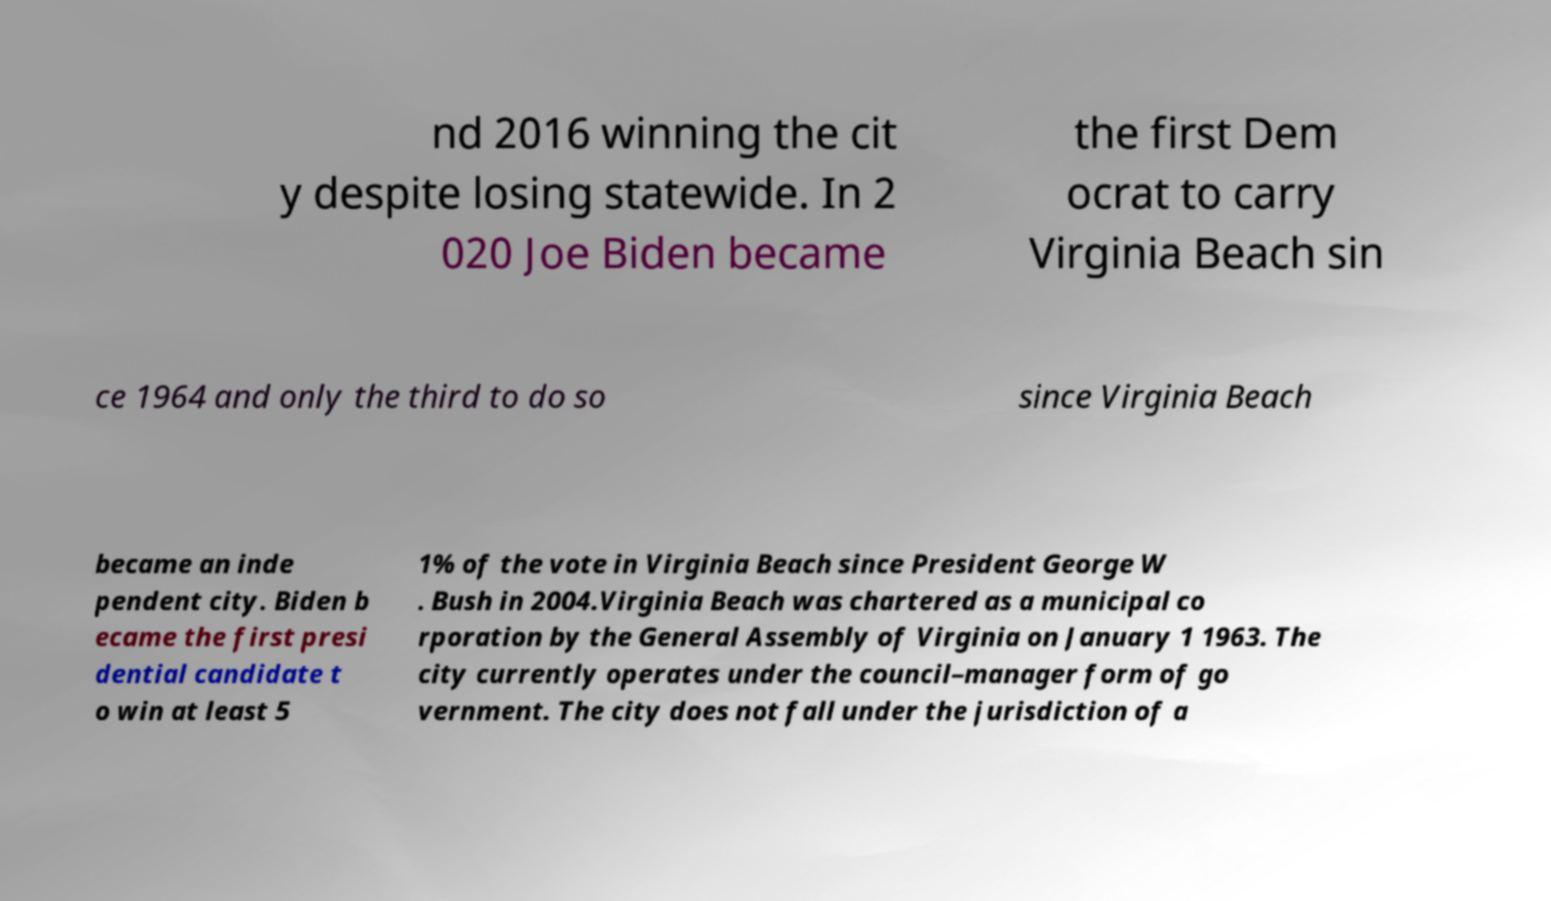Please read and relay the text visible in this image. What does it say? nd 2016 winning the cit y despite losing statewide. In 2 020 Joe Biden became the first Dem ocrat to carry Virginia Beach sin ce 1964 and only the third to do so since Virginia Beach became an inde pendent city. Biden b ecame the first presi dential candidate t o win at least 5 1% of the vote in Virginia Beach since President George W . Bush in 2004.Virginia Beach was chartered as a municipal co rporation by the General Assembly of Virginia on January 1 1963. The city currently operates under the council–manager form of go vernment. The city does not fall under the jurisdiction of a 